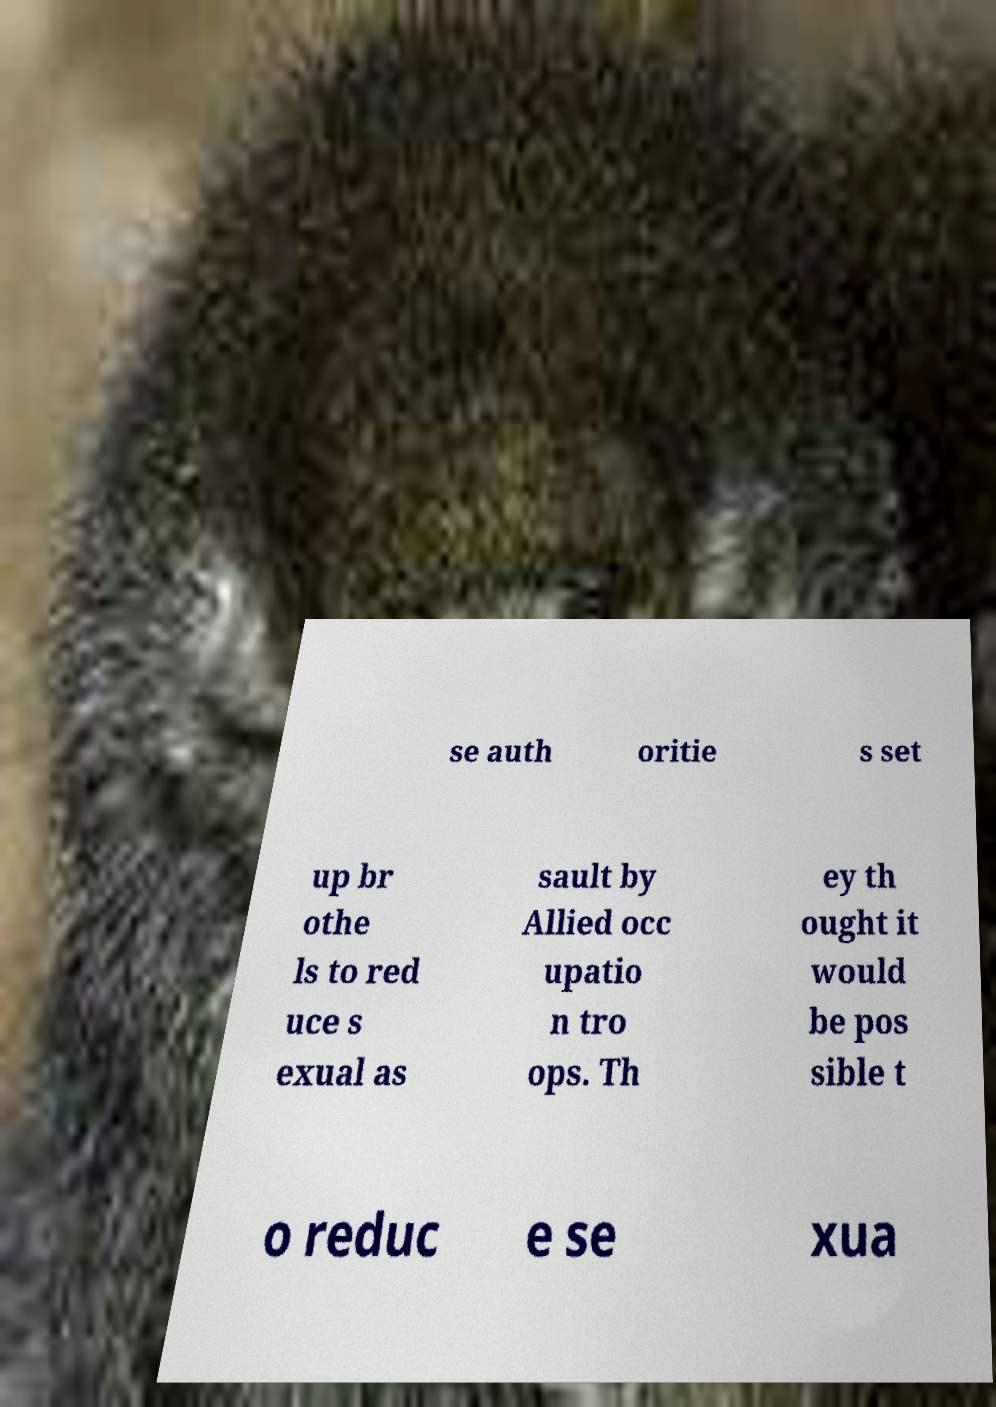Can you accurately transcribe the text from the provided image for me? se auth oritie s set up br othe ls to red uce s exual as sault by Allied occ upatio n tro ops. Th ey th ought it would be pos sible t o reduc e se xua 